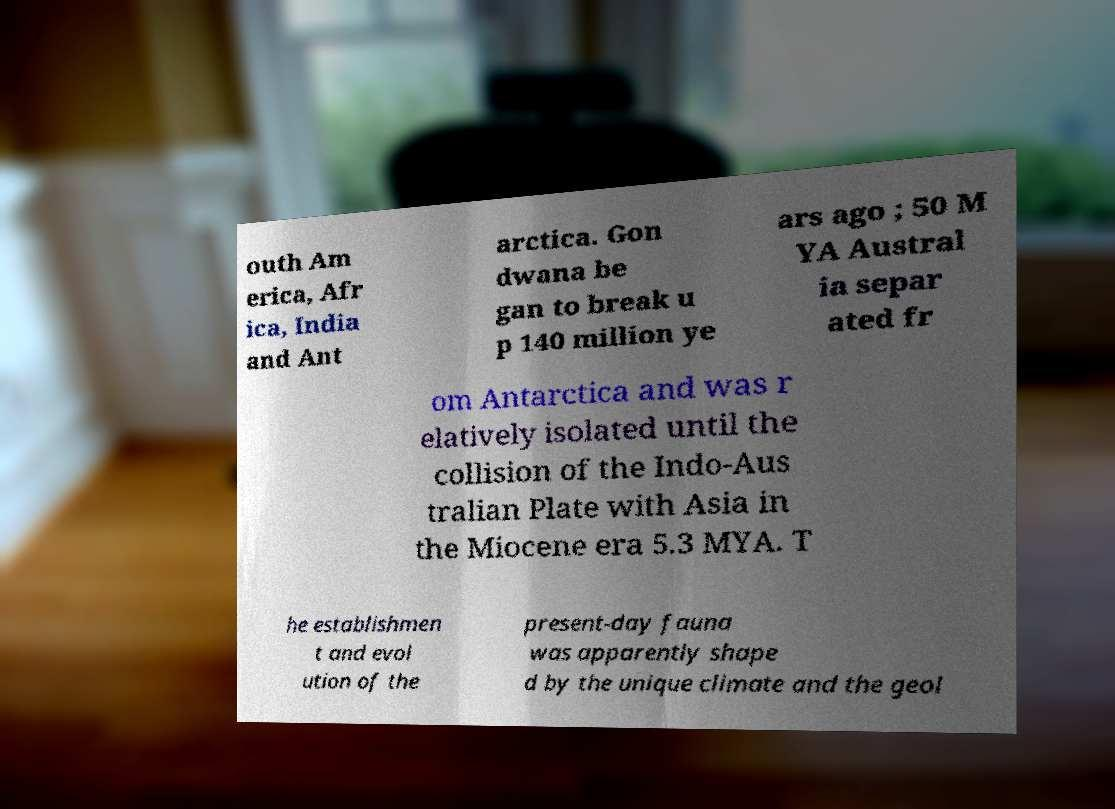What messages or text are displayed in this image? I need them in a readable, typed format. outh Am erica, Afr ica, India and Ant arctica. Gon dwana be gan to break u p 140 million ye ars ago ; 50 M YA Austral ia separ ated fr om Antarctica and was r elatively isolated until the collision of the Indo-Aus tralian Plate with Asia in the Miocene era 5.3 MYA. T he establishmen t and evol ution of the present-day fauna was apparently shape d by the unique climate and the geol 